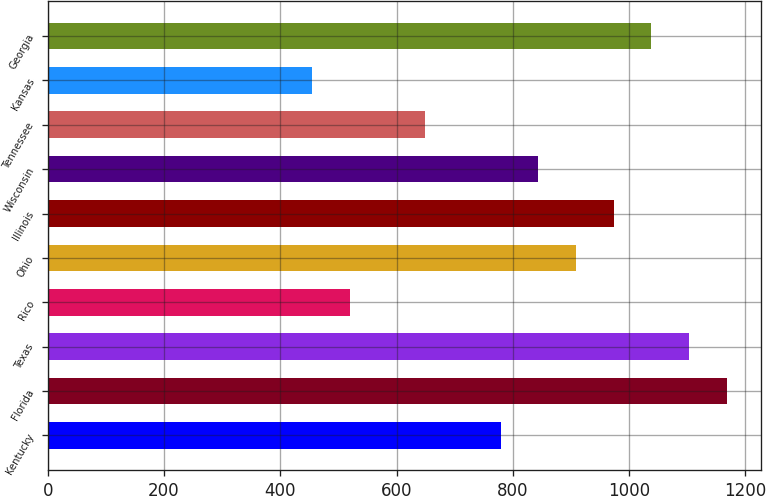<chart> <loc_0><loc_0><loc_500><loc_500><bar_chart><fcel>Kentucky<fcel>Florida<fcel>Texas<fcel>Rico<fcel>Ohio<fcel>Illinois<fcel>Wisconsin<fcel>Tennessee<fcel>Kansas<fcel>Georgia<nl><fcel>779.19<fcel>1168.17<fcel>1103.34<fcel>519.87<fcel>908.85<fcel>973.68<fcel>844.02<fcel>649.53<fcel>455.04<fcel>1038.51<nl></chart> 